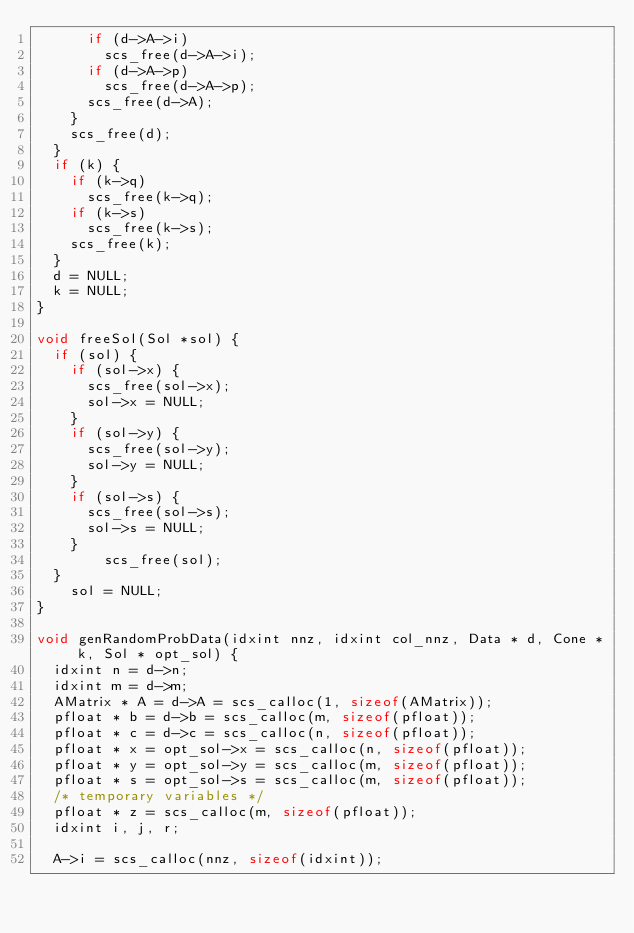<code> <loc_0><loc_0><loc_500><loc_500><_C_>			if (d->A->i)
				scs_free(d->A->i);
			if (d->A->p)
				scs_free(d->A->p);
			scs_free(d->A);
		}
		scs_free(d);
	}
	if (k) {
		if (k->q)
			scs_free(k->q);
		if (k->s)
			scs_free(k->s);
		scs_free(k);
	}
	d = NULL;
	k = NULL;
}

void freeSol(Sol *sol) {
	if (sol) {
		if (sol->x) {
			scs_free(sol->x);
			sol->x = NULL;
		}
		if (sol->y) {
			scs_free(sol->y);
			sol->y = NULL;
		}
		if (sol->s) {
			scs_free(sol->s);
			sol->s = NULL;
		}
        scs_free(sol);
	}
    sol = NULL;
}

void genRandomProbData(idxint nnz, idxint col_nnz, Data * d, Cone * k, Sol * opt_sol) {
	idxint n = d->n;
	idxint m = d->m;
	AMatrix * A = d->A = scs_calloc(1, sizeof(AMatrix));
	pfloat * b = d->b = scs_calloc(m, sizeof(pfloat));
	pfloat * c = d->c = scs_calloc(n, sizeof(pfloat));
	pfloat * x = opt_sol->x = scs_calloc(n, sizeof(pfloat));
	pfloat * y = opt_sol->y = scs_calloc(m, sizeof(pfloat));
	pfloat * s = opt_sol->s = scs_calloc(m, sizeof(pfloat));
	/* temporary variables */
	pfloat * z = scs_calloc(m, sizeof(pfloat));
	idxint i, j, r;

	A->i = scs_calloc(nnz, sizeof(idxint));</code> 